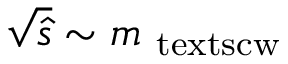Convert formula to latex. <formula><loc_0><loc_0><loc_500><loc_500>\sqrt { \hat { s } } \sim m _ { { \ t e x t s c { w } } }</formula> 